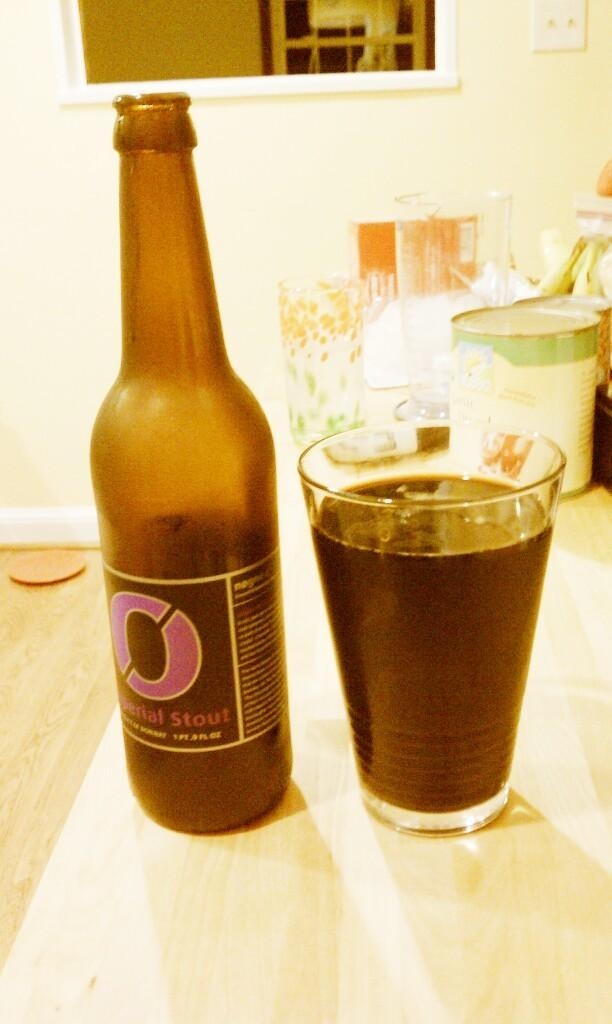<image>
Write a terse but informative summary of the picture. A bottle of imperial stout next to a glass which presumably contains the same. 